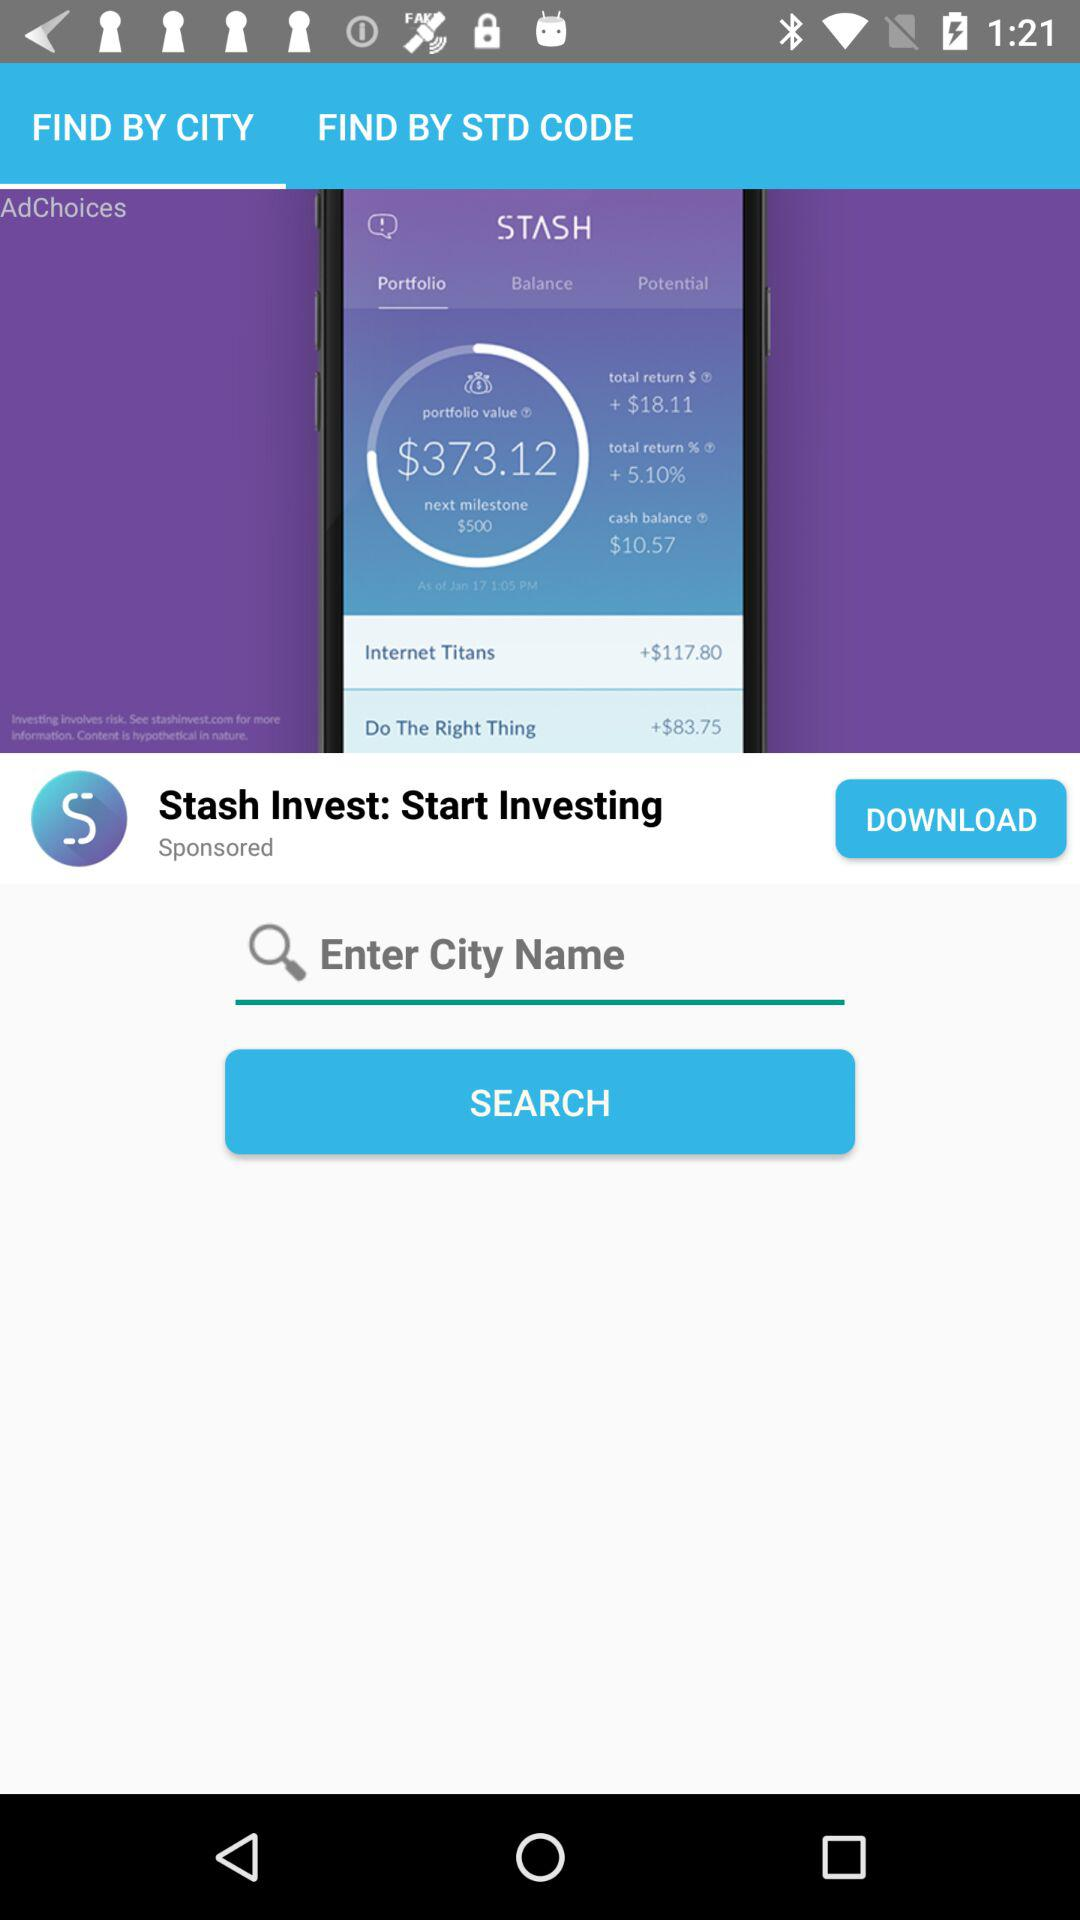What city name is entered?
When the provided information is insufficient, respond with <no answer>. <no answer> 